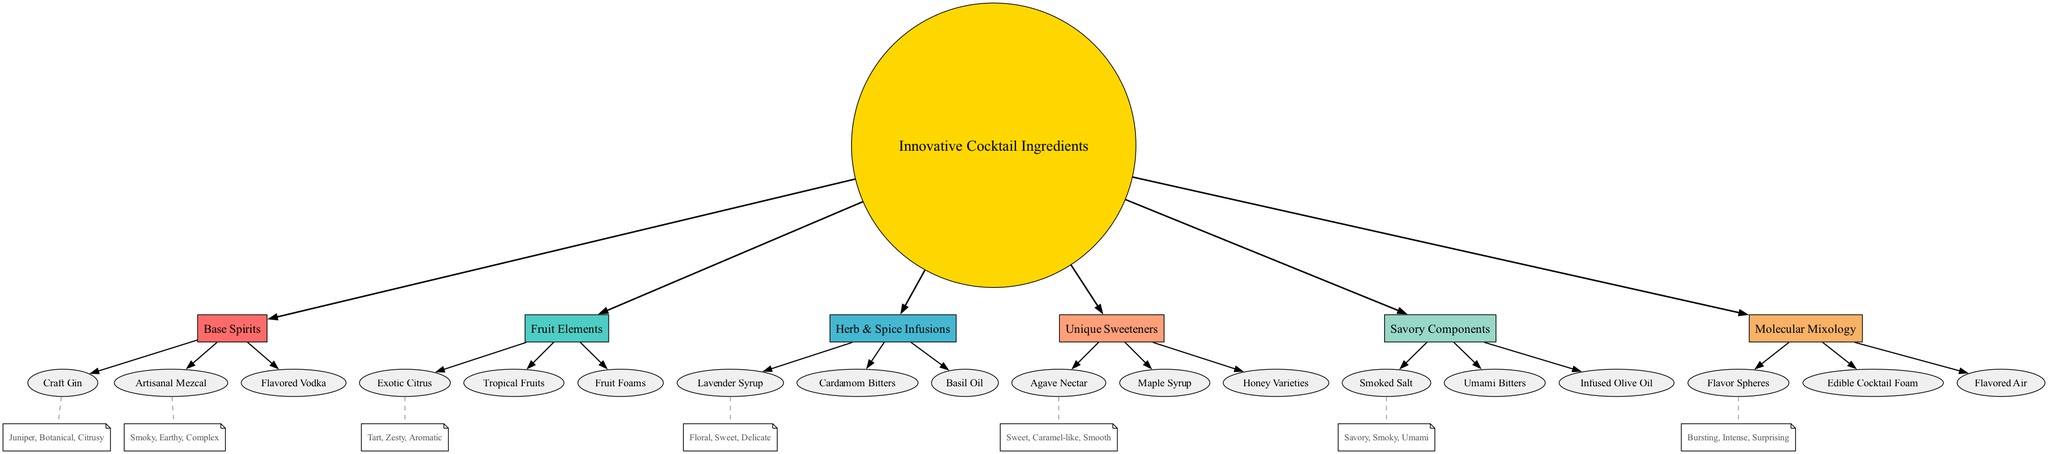What is the central node in the diagram? The central node is indicated at the center of the diagram, labeled "Innovative Cocktail Ingredients." This represents the main theme around which all other nodes are organized.
Answer: Innovative Cocktail Ingredients How many primary categories are there? To count the primary categories, we look at the section labeled "primary_categories" and notice there are six distinct categories listed.
Answer: 6 What subcategory belongs to Base Spirits? Examining the "Base Spirits" category, we find three subcategories listed: Craft Gin, Artisanal Mezcal, and Flavored Vodka. Choosing one, Craft Gin, yields the answer.
Answer: Craft Gin Which flavor profile is associated with Lavender Syrup? Referring to the "flavor_profiles" section, we see that the flavor profile corresponding to Lavender Syrup includes Floral, Sweet, and Delicate.
Answer: Floral, Sweet, Delicate What is the relationship between Exotic Citrus and its flavor profile? The diagram shows that Exotic Citrus connects to its subcategory through a line and denotes a flavor profile. By checking the flavor_profiles section, we can identify that it has the characteristics Tart, Zesty, and Aromatic, establishing this relationship.
Answer: Tart, Zesty, Aromatic Which primary category includes Umami Bitters as a subcategory? By analyzing the subcategories listed under each primary category, we find that Umami Bitters is located in the "Savory Components" section. Hence, this is the primary category that includes it.
Answer: Savory Components What is the color assigned to the Unique Sweeteners category? Each primary category in the diagram is assigned a specific color in the color palette identified in the code. "Unique Sweeteners" corresponds to the fourth color in the list, which is a light orange shade.
Answer: Light Orange Which ingredient has the flavor profile described as "Bursting, Intense, Surprising"? Looking through the flavor profiles, we find that "Flavor Spheres" is associated with the flavor profile descriptors, as indicated in the diagram.
Answer: Flavor Spheres What type of node is used to represent the primary categories? The primary categories are all represented with a specific shape in the diagram, which is a box. This can be determined by inspecting the shape attribute assigned in the creating code.
Answer: Box Which category includes Flavor Spheres and how are they connected? Flavor Spheres is categorized under "Molecular Mixology," connected to it by a directed edge from this primary category in the diagram. This connection indicates that it is part of the Molecular Mixology section.
Answer: Molecular Mixology 